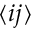<formula> <loc_0><loc_0><loc_500><loc_500>\langle i j \rangle</formula> 